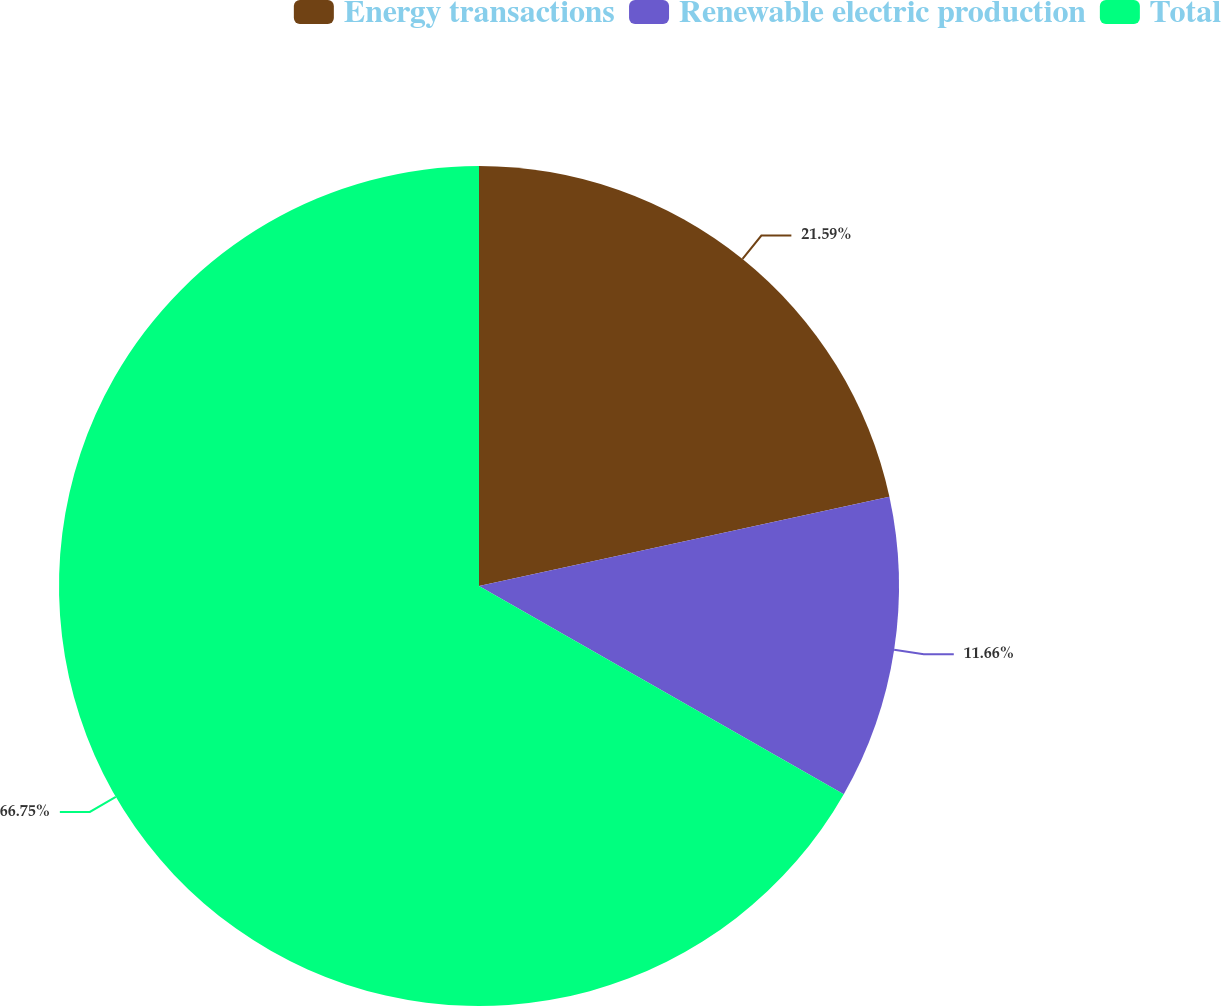Convert chart to OTSL. <chart><loc_0><loc_0><loc_500><loc_500><pie_chart><fcel>Energy transactions<fcel>Renewable electric production<fcel>Total<nl><fcel>21.59%<fcel>11.66%<fcel>66.74%<nl></chart> 